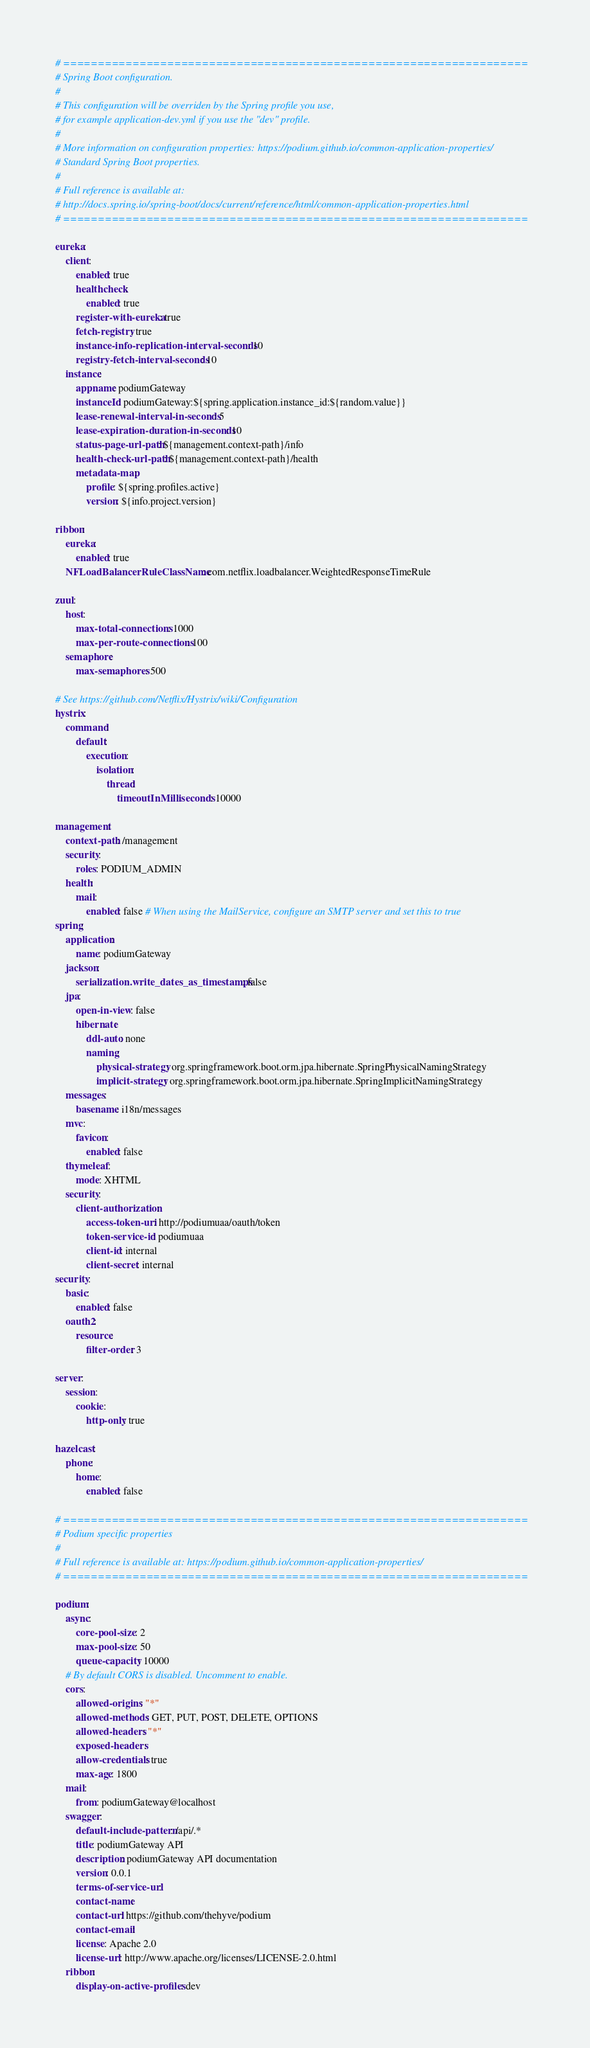Convert code to text. <code><loc_0><loc_0><loc_500><loc_500><_YAML_># ===================================================================
# Spring Boot configuration.
#
# This configuration will be overriden by the Spring profile you use,
# for example application-dev.yml if you use the "dev" profile.
#
# More information on configuration properties: https://podium.github.io/common-application-properties/
# Standard Spring Boot properties.
#
# Full reference is available at:
# http://docs.spring.io/spring-boot/docs/current/reference/html/common-application-properties.html
# ===================================================================

eureka:
    client:
        enabled: true
        healthcheck:
            enabled: true
        register-with-eureka: true
        fetch-registry: true
        instance-info-replication-interval-seconds: 10
        registry-fetch-interval-seconds: 10
    instance:
        appname: podiumGateway
        instanceId: podiumGateway:${spring.application.instance_id:${random.value}}
        lease-renewal-interval-in-seconds: 5
        lease-expiration-duration-in-seconds: 10
        status-page-url-path: ${management.context-path}/info
        health-check-url-path: ${management.context-path}/health
        metadata-map:
            profile: ${spring.profiles.active}
            version: ${info.project.version}

ribbon:
    eureka:
        enabled: true
    NFLoadBalancerRuleClassName: com.netflix.loadbalancer.WeightedResponseTimeRule

zuul:
    host:
        max-total-connections: 1000
        max-per-route-connections: 100
    semaphore:
        max-semaphores: 500

# See https://github.com/Netflix/Hystrix/wiki/Configuration
hystrix:
    command:
        default:
            execution:
                isolation:
                    thread:
                        timeoutInMilliseconds: 10000

management:
    context-path: /management
    security:
        roles: PODIUM_ADMIN
    health:
        mail:
            enabled: false # When using the MailService, configure an SMTP server and set this to true
spring:
    application:
        name: podiumGateway
    jackson:
        serialization.write_dates_as_timestamps: false
    jpa:
        open-in-view: false
        hibernate:
            ddl-auto: none
            naming:
                physical-strategy: org.springframework.boot.orm.jpa.hibernate.SpringPhysicalNamingStrategy
                implicit-strategy: org.springframework.boot.orm.jpa.hibernate.SpringImplicitNamingStrategy
    messages:
        basename: i18n/messages
    mvc:
        favicon:
            enabled: false
    thymeleaf:
        mode: XHTML
    security:
        client-authorization:
            access-token-uri: http://podiumuaa/oauth/token
            token-service-id: podiumuaa
            client-id: internal
            client-secret: internal
security:
    basic:
        enabled: false
    oauth2:
        resource:
            filter-order: 3

server:
    session:
        cookie:
            http-only: true

hazelcast:
    phone:
        home:
            enabled: false

# ===================================================================
# Podium specific properties
#
# Full reference is available at: https://podium.github.io/common-application-properties/
# ===================================================================

podium:
    async:
        core-pool-size: 2
        max-pool-size: 50
        queue-capacity: 10000
    # By default CORS is disabled. Uncomment to enable.
    cors:
        allowed-origins: "*"
        allowed-methods: GET, PUT, POST, DELETE, OPTIONS
        allowed-headers: "*"
        exposed-headers:
        allow-credentials: true
        max-age: 1800
    mail:
        from: podiumGateway@localhost
    swagger:
        default-include-pattern: /api/.*
        title: podiumGateway API
        description: podiumGateway API documentation
        version: 0.0.1
        terms-of-service-url:
        contact-name:
        contact-url: https://github.com/thehyve/podium
        contact-email:
        license: Apache 2.0
        license-url: http://www.apache.org/licenses/LICENSE-2.0.html
    ribbon:
        display-on-active-profiles: dev
</code> 